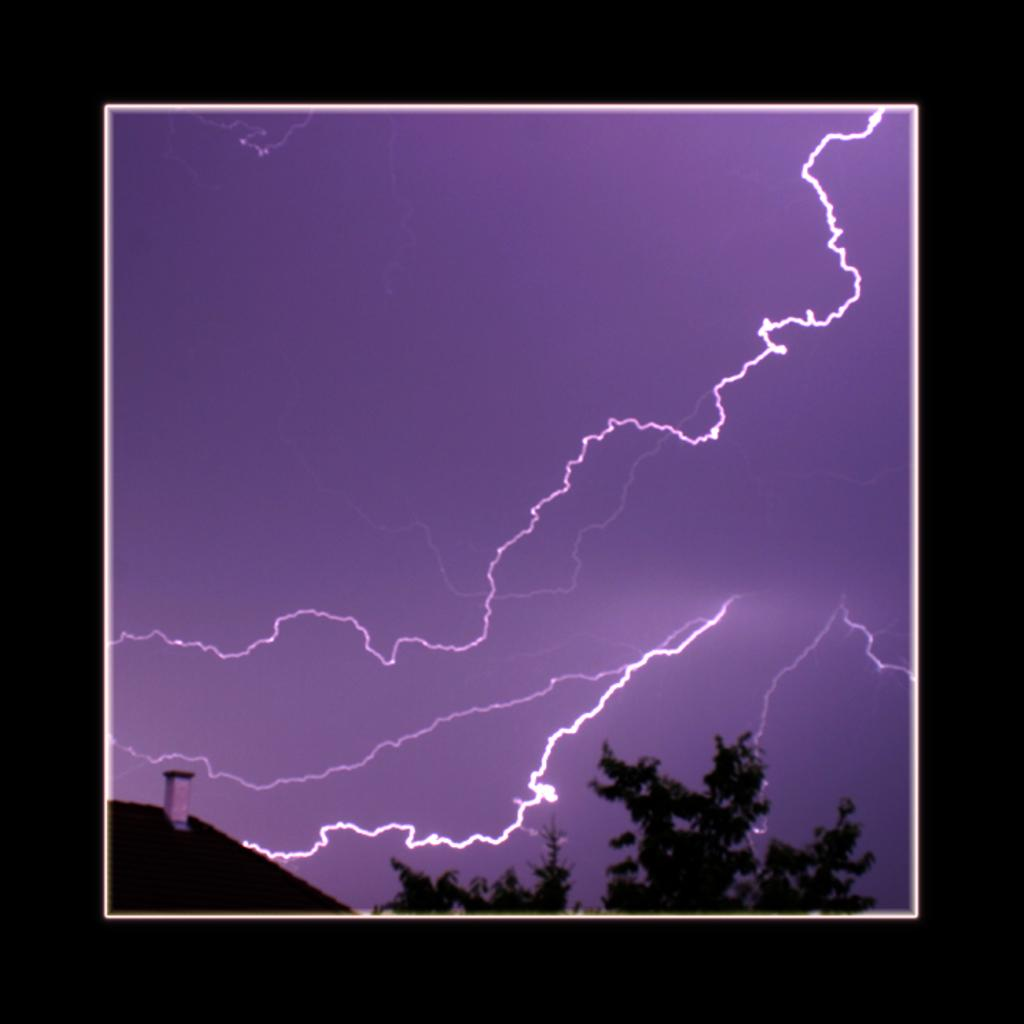What type of structure is present in the image? There is a house in the image. What other natural element can be seen in the image? There is a tree in the image. What is happening in the sky in the background of the image? There are thunders visible in the sky in the background of the image. What type of quartz can be seen on the roof of the house in the image? There is no quartz visible on the roof of the house in the image. 